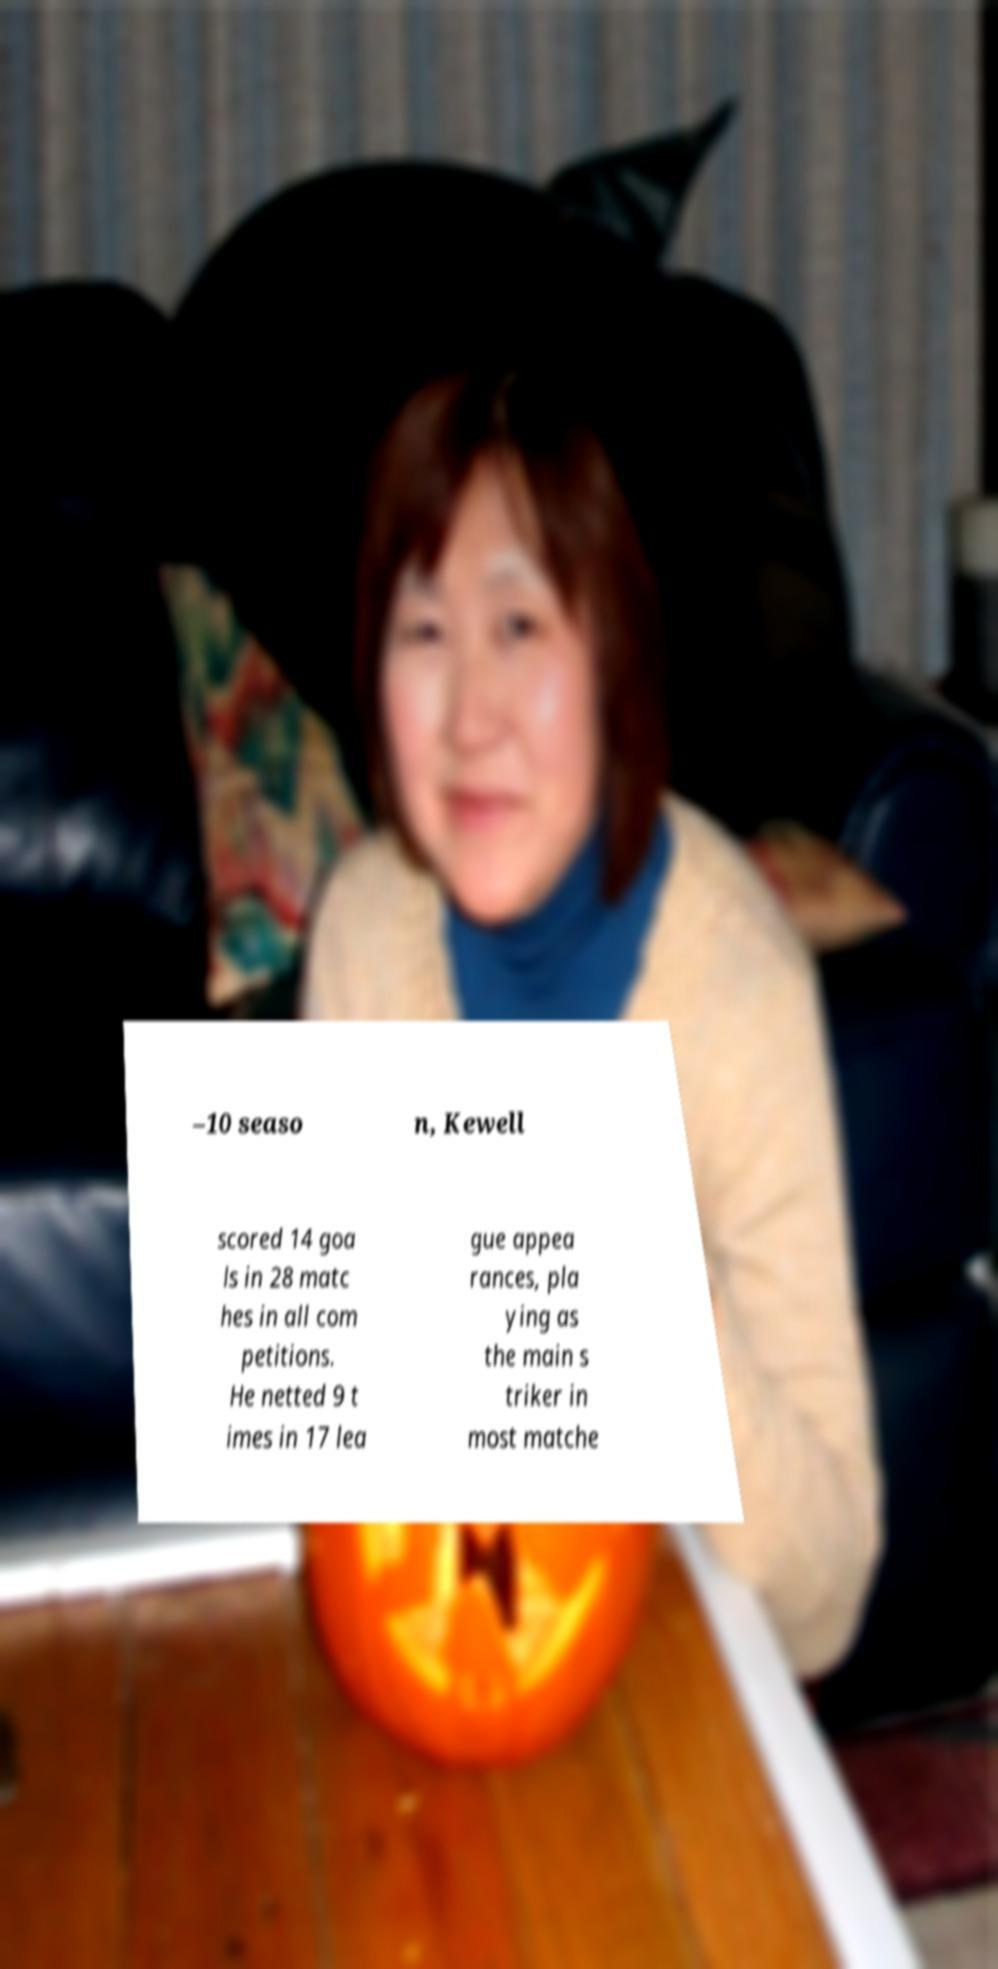Can you accurately transcribe the text from the provided image for me? –10 seaso n, Kewell scored 14 goa ls in 28 matc hes in all com petitions. He netted 9 t imes in 17 lea gue appea rances, pla ying as the main s triker in most matche 